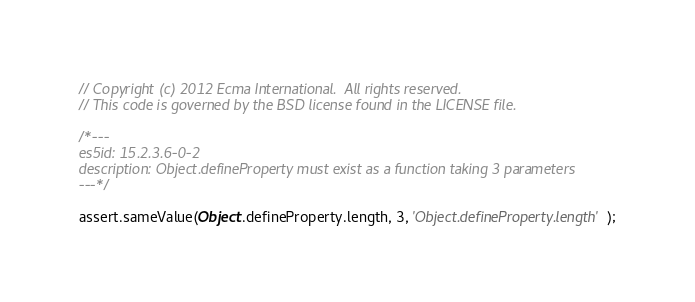Convert code to text. <code><loc_0><loc_0><loc_500><loc_500><_JavaScript_>// Copyright (c) 2012 Ecma International.  All rights reserved.
// This code is governed by the BSD license found in the LICENSE file.

/*---
es5id: 15.2.3.6-0-2
description: Object.defineProperty must exist as a function taking 3 parameters
---*/

assert.sameValue(Object.defineProperty.length, 3, 'Object.defineProperty.length');
</code> 